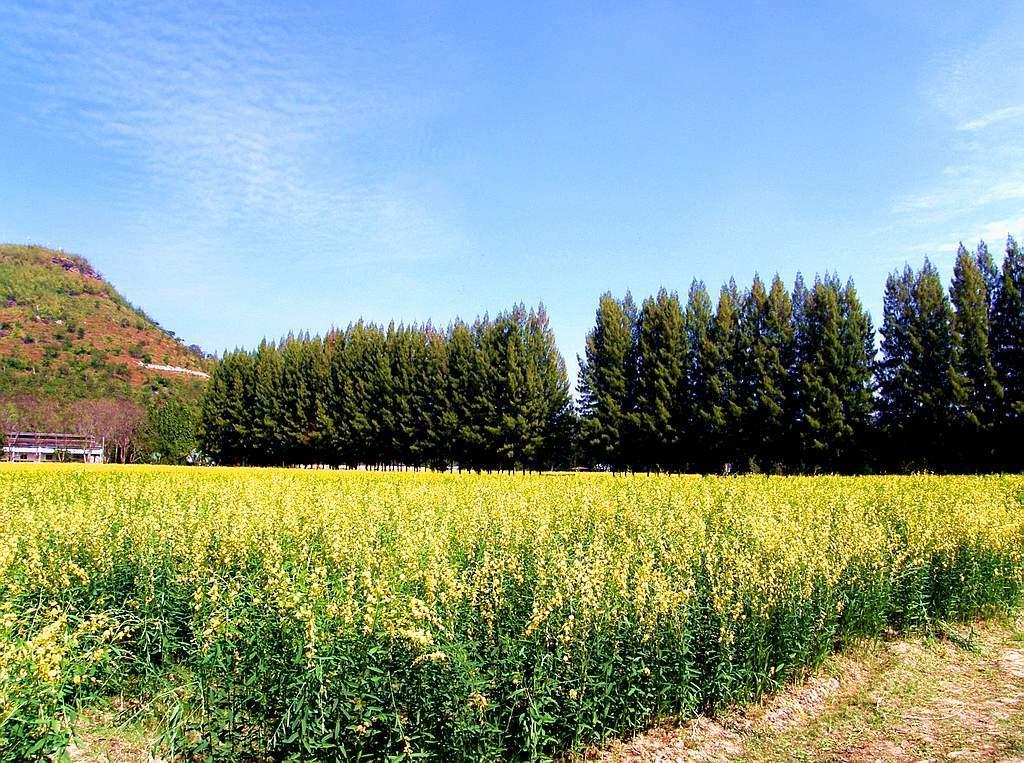In one or two sentences, can you explain what this image depicts? In this image there are plants on the ground. Behind them there are trees. In the background there is a mountain. There are plants on the mountain. At the top there is the sky. 